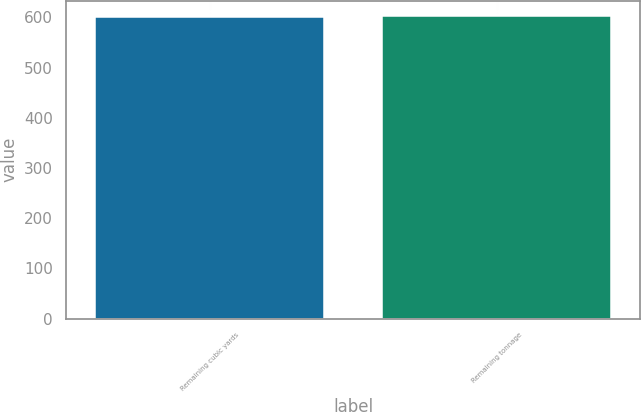Convert chart. <chart><loc_0><loc_0><loc_500><loc_500><bar_chart><fcel>Remaining cubic yards<fcel>Remaining tonnage<nl><fcel>600<fcel>603<nl></chart> 